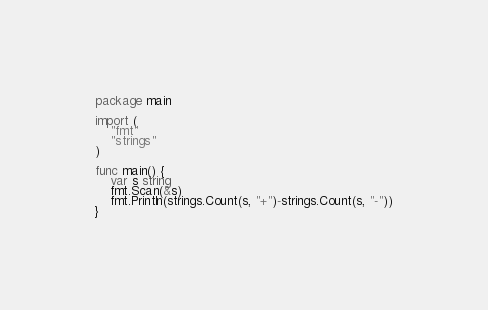<code> <loc_0><loc_0><loc_500><loc_500><_Go_>package main

import (
	"fmt"
	"strings"
)

func main() {
	var s string
	fmt.Scan(&s)
	fmt.Println(strings.Count(s, "+")-strings.Count(s, "-"))
}</code> 